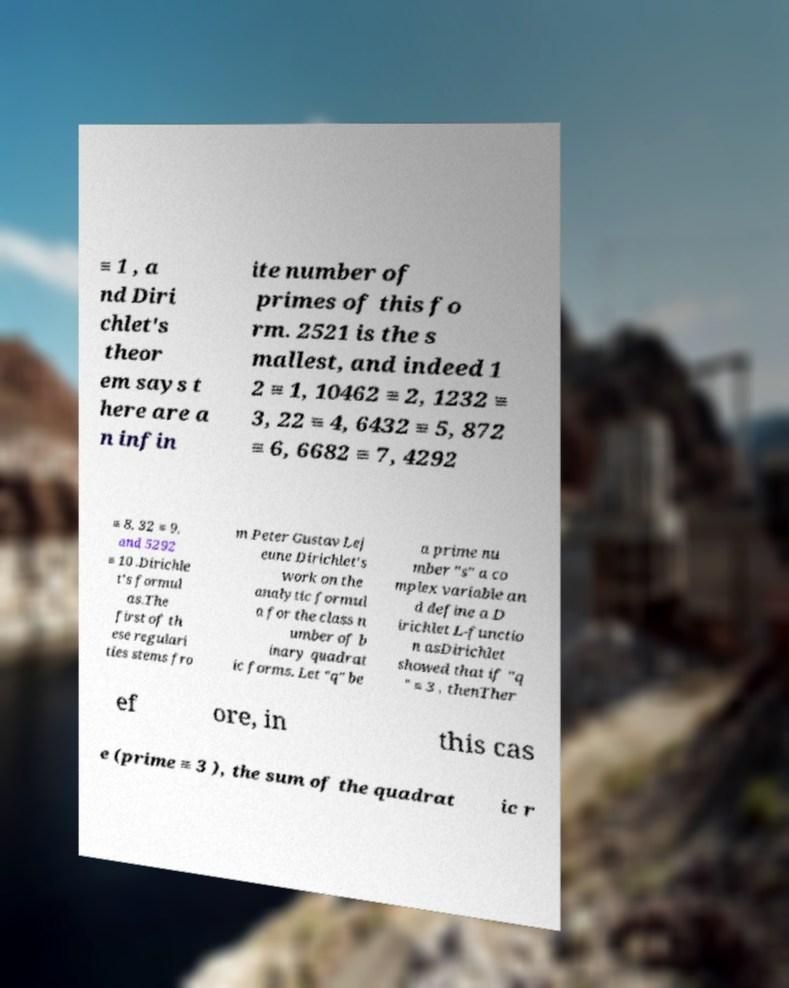Can you read and provide the text displayed in the image?This photo seems to have some interesting text. Can you extract and type it out for me? ≡ 1 , a nd Diri chlet's theor em says t here are a n infin ite number of primes of this fo rm. 2521 is the s mallest, and indeed 1 2 ≡ 1, 10462 ≡ 2, 1232 ≡ 3, 22 ≡ 4, 6432 ≡ 5, 872 ≡ 6, 6682 ≡ 7, 4292 ≡ 8, 32 ≡ 9, and 5292 ≡ 10 .Dirichle t's formul as.The first of th ese regulari ties stems fro m Peter Gustav Lej eune Dirichlet's work on the analytic formul a for the class n umber of b inary quadrat ic forms. Let "q" be a prime nu mber "s" a co mplex variable an d define a D irichlet L-functio n asDirichlet showed that if "q " ≡ 3 , thenTher ef ore, in this cas e (prime ≡ 3 ), the sum of the quadrat ic r 